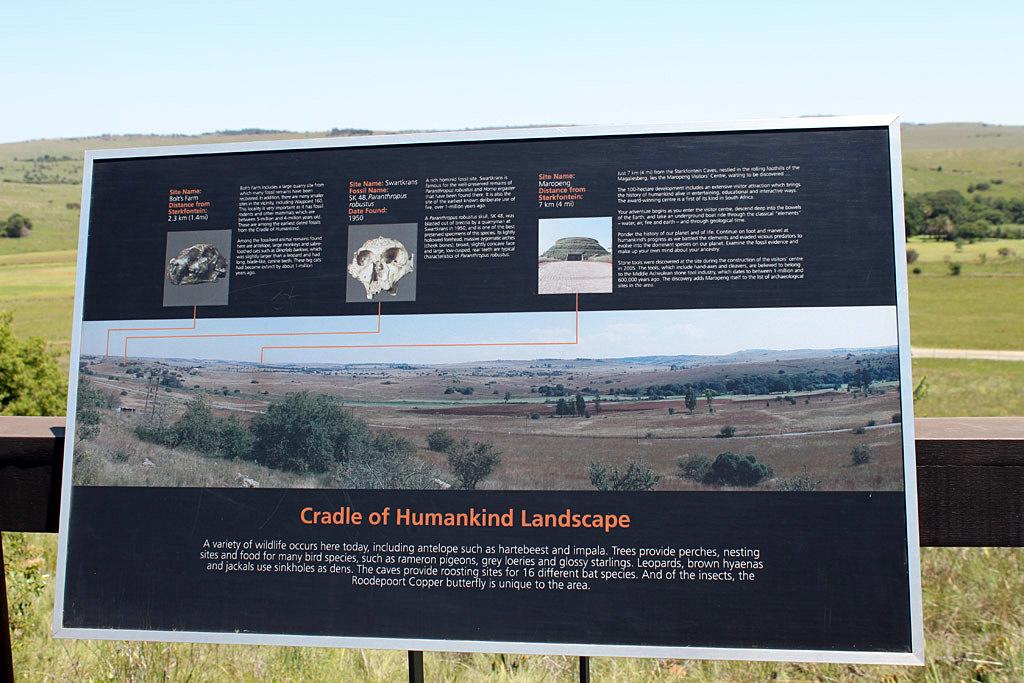What does the cradle of humankind refer to?
Give a very brief answer. Landscape. 